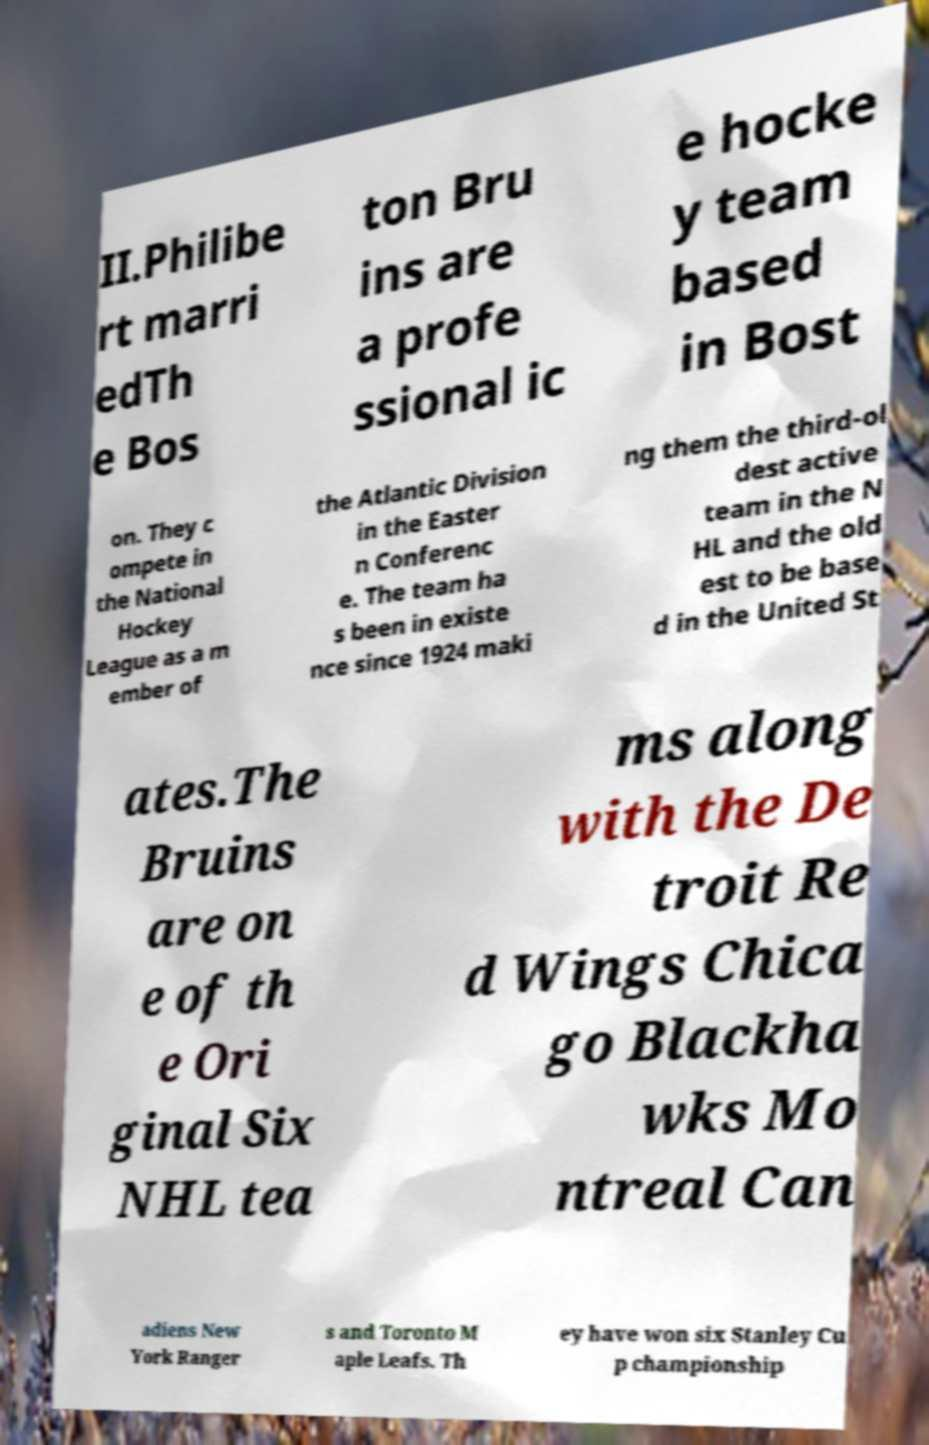Could you extract and type out the text from this image? II.Philibe rt marri edTh e Bos ton Bru ins are a profe ssional ic e hocke y team based in Bost on. They c ompete in the National Hockey League as a m ember of the Atlantic Division in the Easter n Conferenc e. The team ha s been in existe nce since 1924 maki ng them the third-ol dest active team in the N HL and the old est to be base d in the United St ates.The Bruins are on e of th e Ori ginal Six NHL tea ms along with the De troit Re d Wings Chica go Blackha wks Mo ntreal Can adiens New York Ranger s and Toronto M aple Leafs. Th ey have won six Stanley Cu p championship 